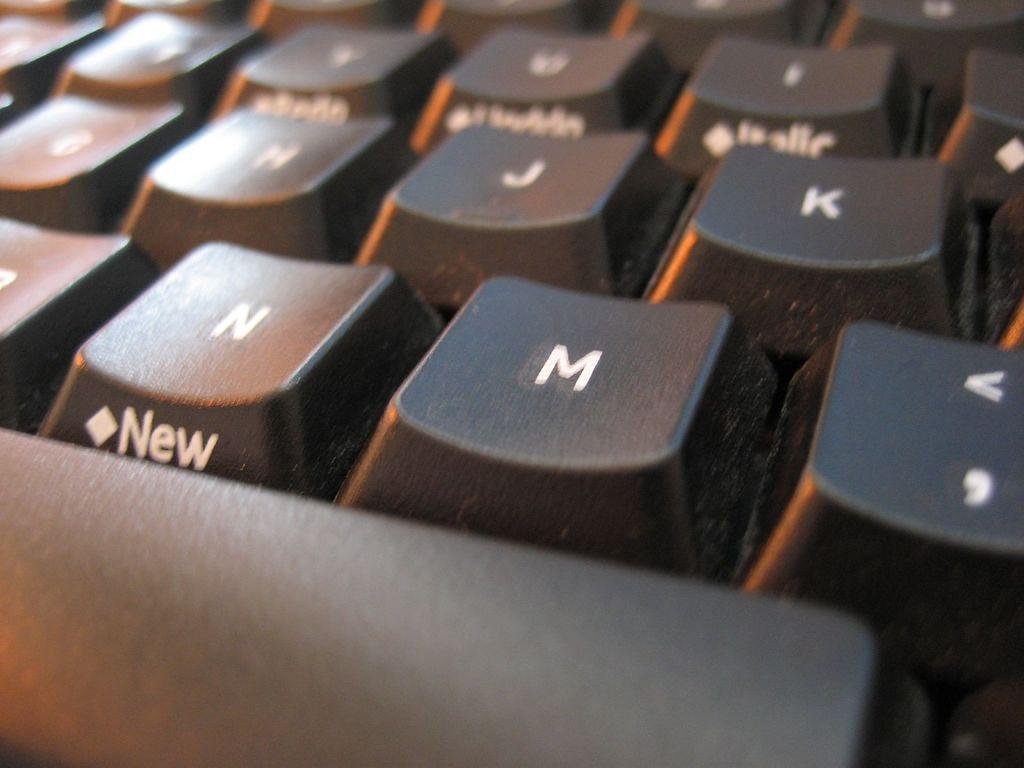<image>
Relay a brief, clear account of the picture shown. A closeup of a computer keyboard showing the M key front and center. 